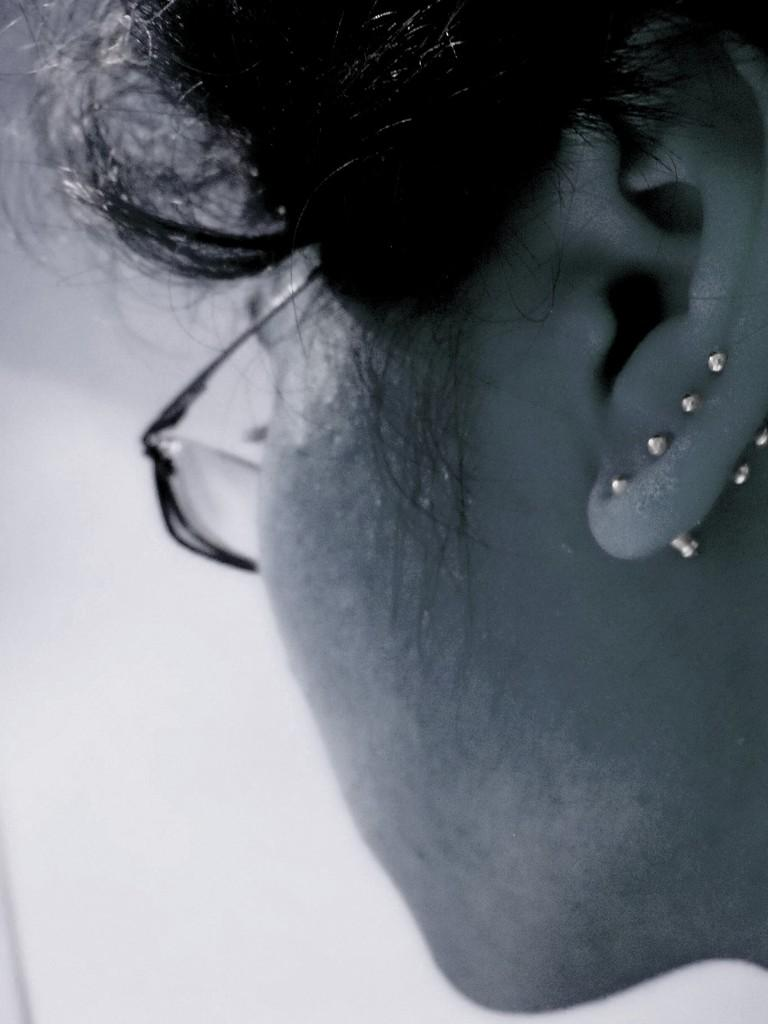What is the color scheme of the image? The image is black and white. What can be seen in the image? There is a person's face in the image. What accessory is the person wearing in the image? The person is wearing spectacles. What type of pan is visible in the image? There is no pan present in the image. What property does the person own in the image? The image does not show any property owned by the person. 